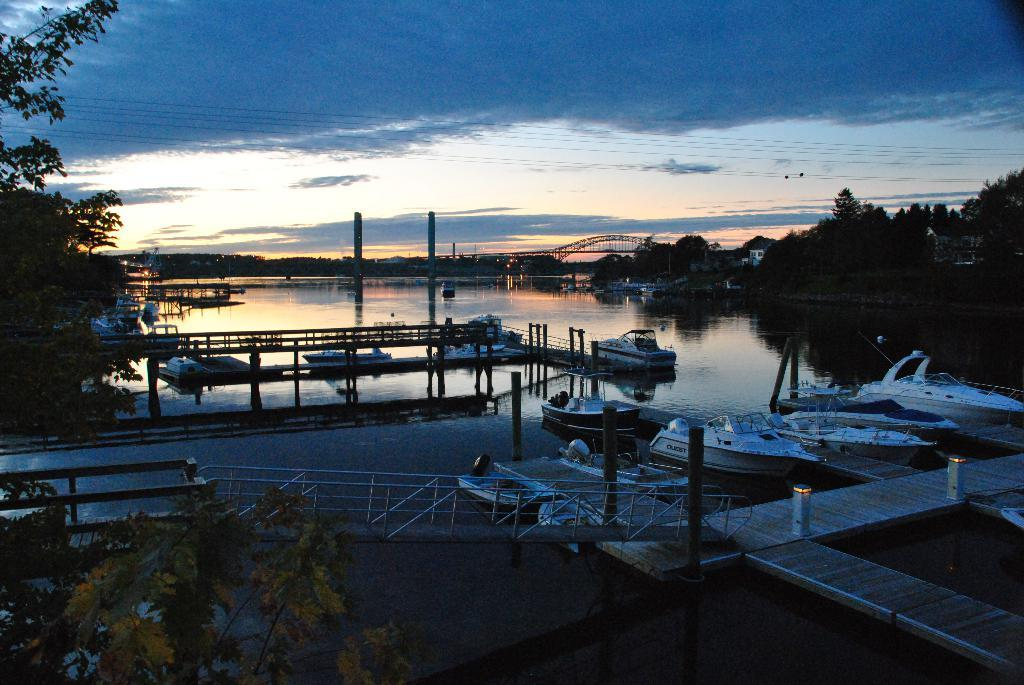What is positioned above the water in the image? There are boats above the water in the image. What structure can be seen in the image? There is a bridge in the image. What feature is present along the bridge? There is railing in the image. What type of vegetation is on the left side of the image? There are trees on the left side of the image. What can be seen in the background of the image? There are trees, a tower, wires, and the sky visible in the background of the image. What is the condition of the sky in the image? The sky is visible in the background of the image, and there are clouds present. What type of theory is being discussed in the library in the image? There is no library present in the image, and therefore no theory can be discussed. What is the mouth of the person in the image doing? There are no people present in the image, so there is no mouth to describe. 